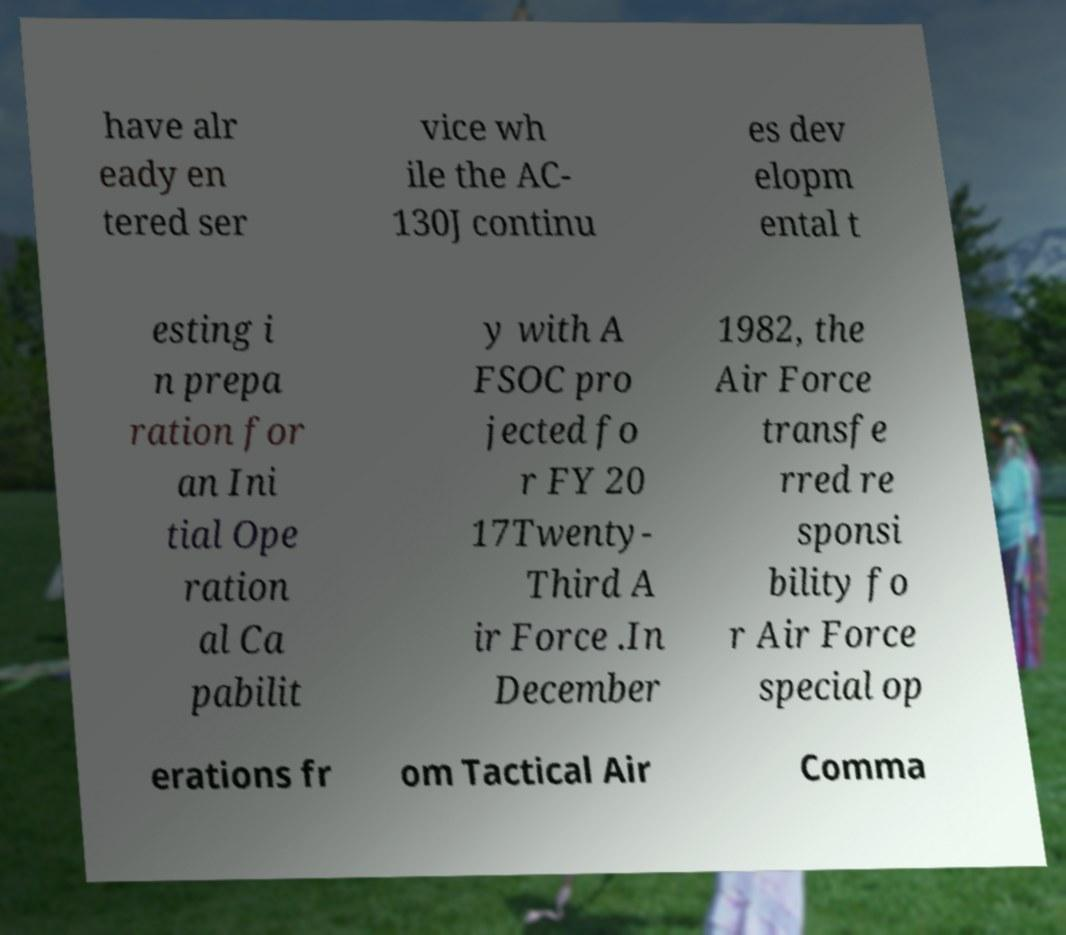Can you read and provide the text displayed in the image?This photo seems to have some interesting text. Can you extract and type it out for me? have alr eady en tered ser vice wh ile the AC- 130J continu es dev elopm ental t esting i n prepa ration for an Ini tial Ope ration al Ca pabilit y with A FSOC pro jected fo r FY 20 17Twenty- Third A ir Force .In December 1982, the Air Force transfe rred re sponsi bility fo r Air Force special op erations fr om Tactical Air Comma 